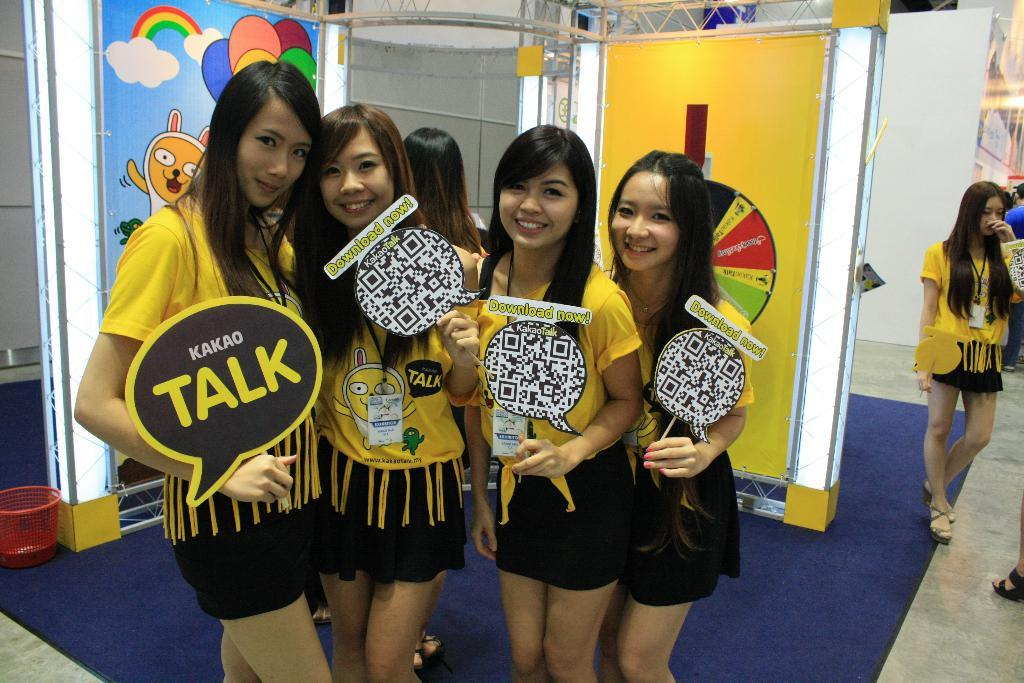<image>
Offer a succinct explanation of the picture presented. Girls in a row and one has a sign that says Kakao talk. 